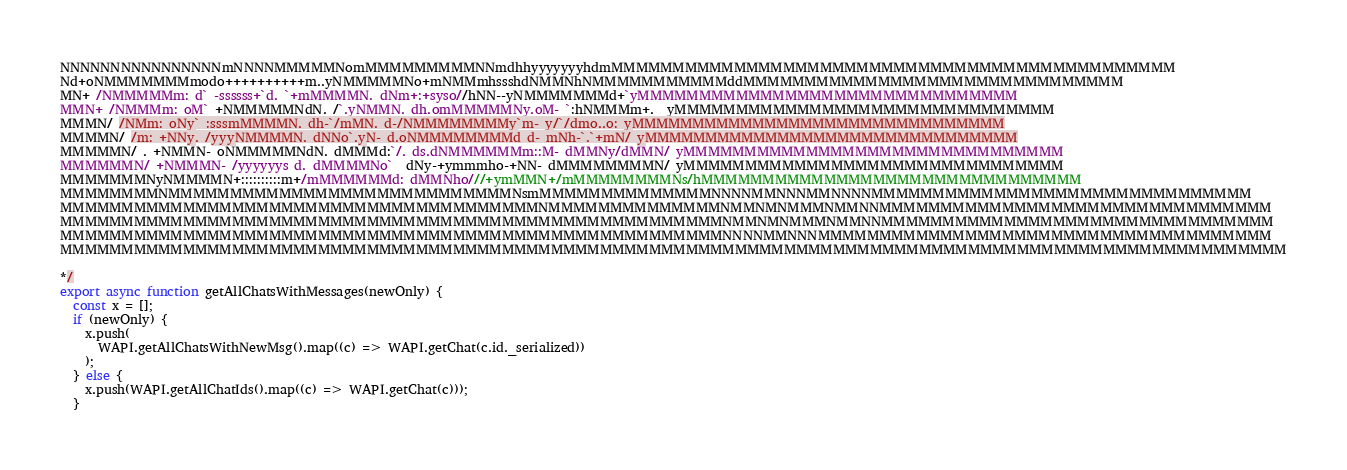<code> <loc_0><loc_0><loc_500><loc_500><_JavaScript_>NNNNNNNNNNNNNNNNmNNNNMMMMMNomMMMMMMMMMNNmdhhyyyyyyyhdmMMMMMMMMMMMMMMMMMMMMMMMMMMMMMMMMMMMMMMMMMMMMMM
Nd+oNMMMMMMMmodo++++++++++m..yNMMMMMNo+mNMMmhssshdNMMNhNMMMMMMMMMMMddMMMMMMMMMMMMMMMMMMMMMMMMMMMMMMM
MN+ /NMMMMMm: d` -ssssss+`d. `+mMMMMN. dNm+:+syso//hNN--yNMMMMMMMd+`yMMMMMMMMMMMMMMMMMMMMMMMMMMMMMMM
MMN+ /NMMMm: oM` +NMMMMMNdN. /`.yNMMN. dh.omMMMMMNy.oM- `:hNMMMm+.  yMMMMMMMMMMMMMMMMMMMMMMMMMMMMMMM
MMMN/ /NMm: oNy` :sssmMMMMN. dh-`/mMN. d-/NMMMMMMMMy`m- y/`/dmo..o: yMMMMMMMMMMMMMMMMMMMMMMMMMMMMMMM
MMMMN/ /m: +NNy. /yyyNMMMMN. dNNo`.yN- d.oNMMMMMMMMd d- mNh-`.`+mN/ yMMMMMMMMMMMMMMMMMMMMMMMMMMMMMMM
MMMMMN/ . +NMMN- oNMMMMMNdN. dMMMd:`/. ds.dNMMMMMMm::M- dMMNy/dMMN/ yMMMMMMMMMMMMMMMMMMMMMMMMMMMMMMM
MMMMMMN/ +NMMMN- /yyyyyys d. dMMMMNo`  dNy-+ymmmho-+NN- dMMMMMMMMN/ yMMMMMMMMMMMMMMMMMMMMMMMMMMMMMMM
MMMMMMMNyNMMMMN+::::::::::m+/mMMMMMMd: dMMNho///+ymMMN+/mMMMMMMMMNs/hMMMMMMMMMMMMMMMMMMMMMMMMMMMMMMM
MMMMMMMMNMMMMMMMMMMMMMMMMMMMMMMMMMMMMNsmMMMMMMMMMMMMMMNNNNMMNNNMMNNNNMMMMMMMMMMMMMMMMMMMMMMMMMMMMMMM
MMMMMMMMMMMMMMMMMMMMMMMMMMMMMMMMMMMMMMMNMMMMMMMMMMMMMMNMMNMNMMMNMMNNMMMMMMMMMMMMMMMMMMMMMMMMMMMMMMMM
MMMMMMMMMMMMMMMMMMMMMMMMMMMMMMMMMMMMMMMMMMMMMMMMMMMMMMNMMNMNMMMNMMNNMMMMMMMMMMMMMMMMMMMMMMMMMMMMMMMM
MMMMMMMMMMMMMMMMMMMMMMMMMMMMMMMMMMMMMMMMMMMMMMMMMMMMMMNNNNMMNNNMMMMMMMMMMMMMMMMMMMMMMMMMMMMMMMMMMMMM
MMMMMMMMMMMMMMMMMMMMMMMMMMMMMMMMMMMMMMMMMMMMMMMMMMMMMMMMMMMMMMMMMMMMMMMMMMMMMMMMMMMMMMMMMMMMMMMMMMMM

*/
export async function getAllChatsWithMessages(newOnly) {
  const x = [];
  if (newOnly) {
    x.push(
      WAPI.getAllChatsWithNewMsg().map((c) => WAPI.getChat(c.id._serialized))
    );
  } else {
    x.push(WAPI.getAllChatIds().map((c) => WAPI.getChat(c)));
  }</code> 